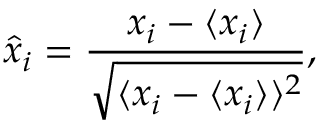<formula> <loc_0><loc_0><loc_500><loc_500>\hat { x } _ { i } = \frac { x _ { i } - \langle x _ { i } \rangle } { \sqrt { \langle x _ { i } - \langle x _ { i } \rangle \rangle ^ { 2 } } } ,</formula> 